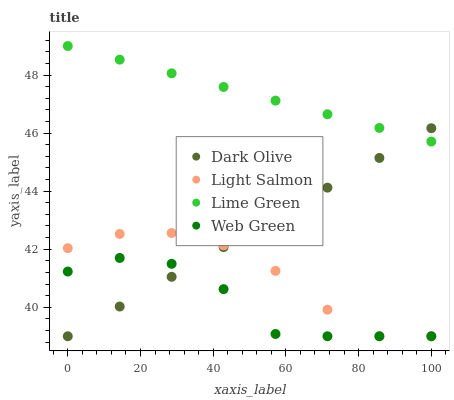Does Web Green have the minimum area under the curve?
Answer yes or no. Yes. Does Lime Green have the maximum area under the curve?
Answer yes or no. Yes. Does Dark Olive have the minimum area under the curve?
Answer yes or no. No. Does Dark Olive have the maximum area under the curve?
Answer yes or no. No. Is Lime Green the smoothest?
Answer yes or no. Yes. Is Web Green the roughest?
Answer yes or no. Yes. Is Dark Olive the smoothest?
Answer yes or no. No. Is Dark Olive the roughest?
Answer yes or no. No. Does Light Salmon have the lowest value?
Answer yes or no. Yes. Does Lime Green have the lowest value?
Answer yes or no. No. Does Lime Green have the highest value?
Answer yes or no. Yes. Does Dark Olive have the highest value?
Answer yes or no. No. Is Light Salmon less than Lime Green?
Answer yes or no. Yes. Is Lime Green greater than Web Green?
Answer yes or no. Yes. Does Light Salmon intersect Dark Olive?
Answer yes or no. Yes. Is Light Salmon less than Dark Olive?
Answer yes or no. No. Is Light Salmon greater than Dark Olive?
Answer yes or no. No. Does Light Salmon intersect Lime Green?
Answer yes or no. No. 